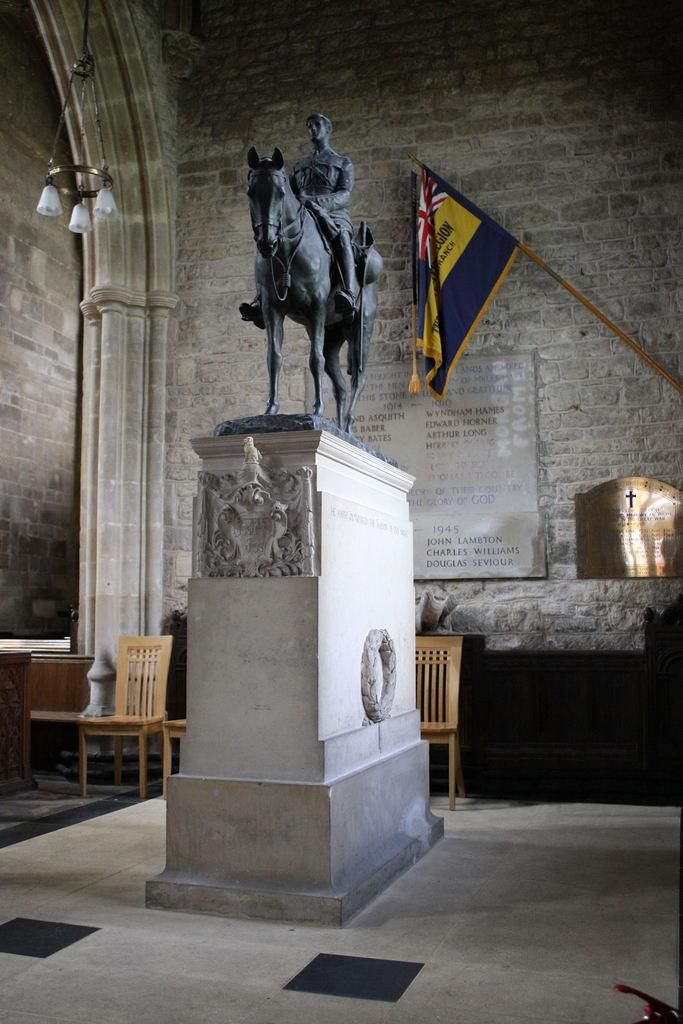What is the main subject in the image? There is a statue in the image. What can be seen in the background of the image? There is a wall in the background of the image. What is attached to the wall? There is a flag on the wall and two shields on the wall. What is written on the shields? There is text on the shields. What furniture is near the wall? There are chairs near the wall. What substance is leaking from the pocket of the statue in the image? There is no pocket on the statue in the image, and therefore no substance can be leaking from it. 